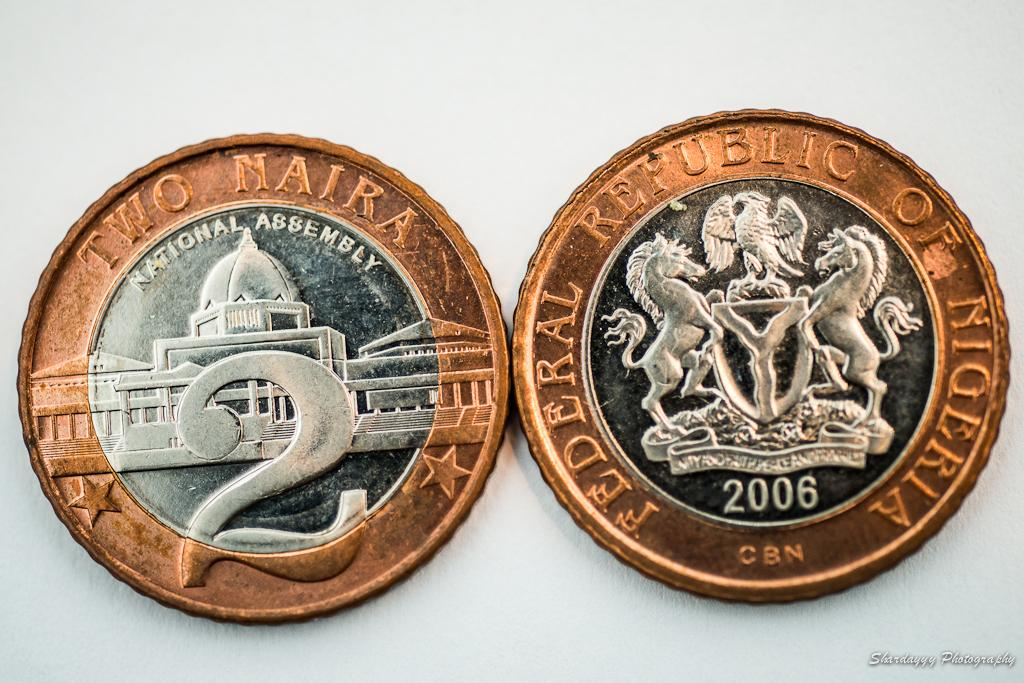<image>
Provide a brief description of the given image. two bronze and silver coins for Two Naira from Nigeria 